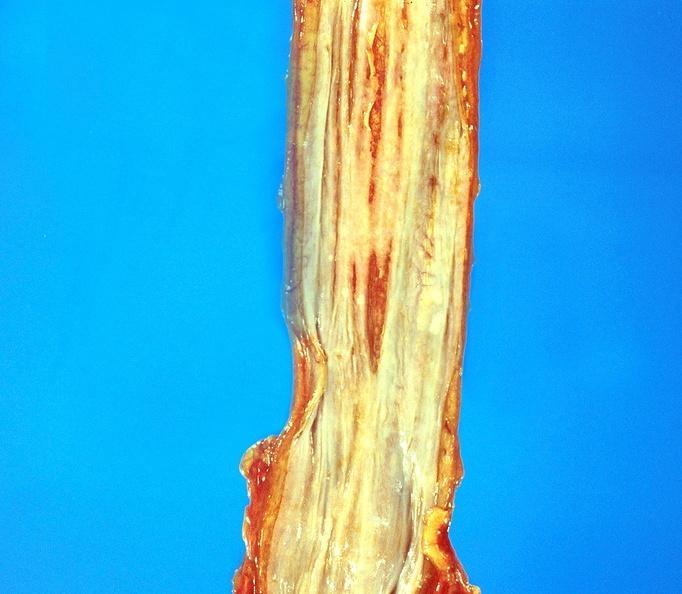where does this belong to?
Answer the question using a single word or phrase. Gastrointestinal system 